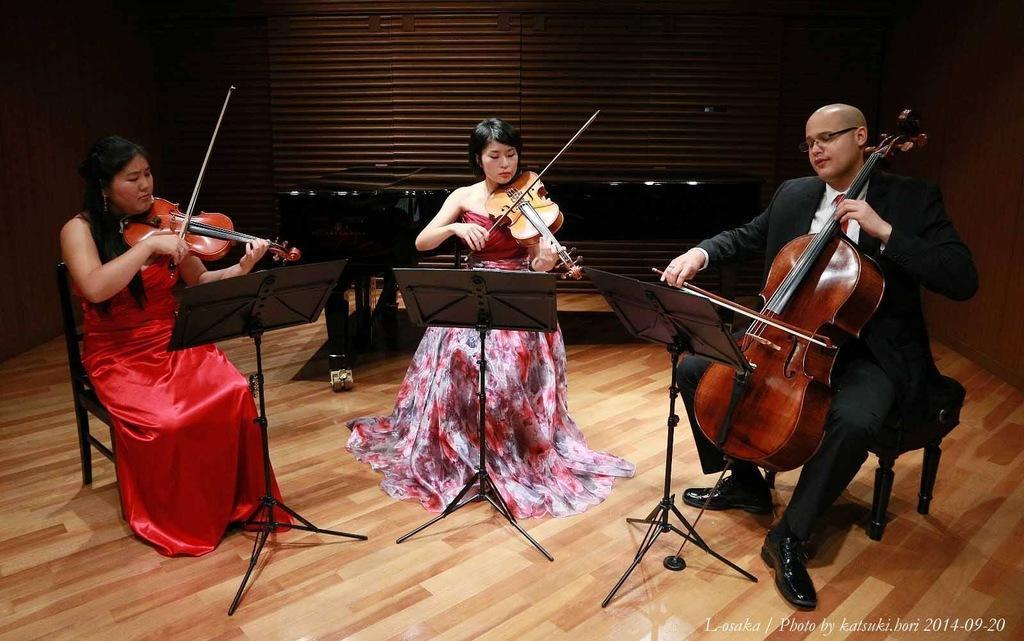In one or two sentences, can you explain what this image depicts? In this picture there are three people who are sitting on the chair are playing violin. There are two woman and a man. 